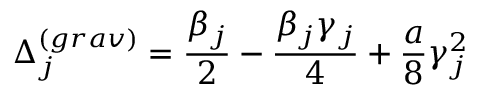<formula> <loc_0><loc_0><loc_500><loc_500>\Delta _ { j } ^ { ( g r a v ) } = \frac { \beta _ { j } } { 2 } - \frac { \beta _ { j } \gamma _ { j } } { 4 } + \frac { a } { 8 } \gamma _ { j } ^ { 2 }</formula> 